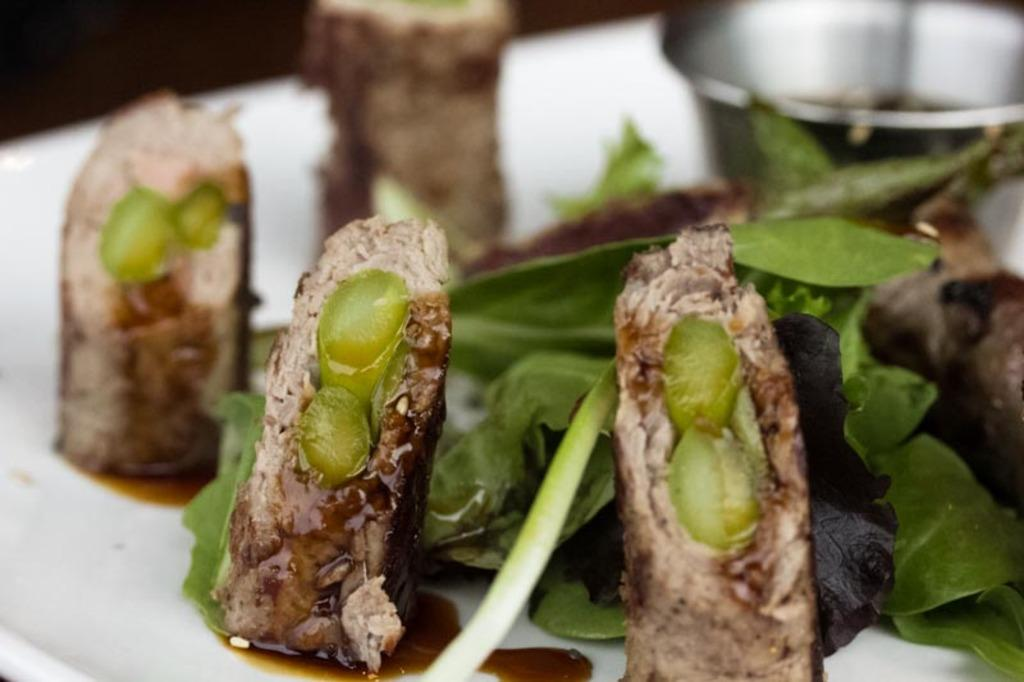What types of items can be seen in the image? There are food items, leaves, and a bowl in the image. How are the food items, leaves, and bowl arranged in the image? They are placed on a plate in the image. What is the color of the background in the image? The background of the image is dark. What type of pen can be seen on the plate in the image? There is no pen present on the plate in the image. What kind of rod is used to hold the food items in the image? There is no rod used to hold the food items in the image; they are placed on a plate. 